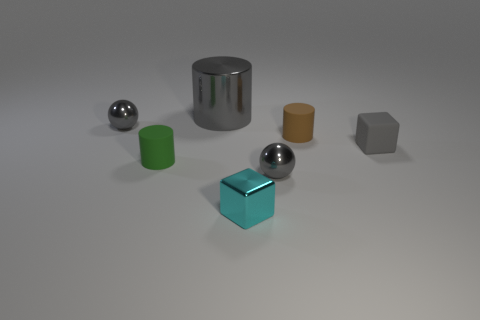Do the large cylinder and the small cylinder that is on the left side of the large gray metallic thing have the same material?
Give a very brief answer. No. The small gray shiny object in front of the metallic thing that is on the left side of the tiny green object is what shape?
Ensure brevity in your answer.  Sphere. There is a gray metallic sphere that is in front of the green object; is it the same size as the big gray object?
Offer a terse response. No. What number of other things are the same shape as the big gray thing?
Give a very brief answer. 2. There is a tiny ball that is behind the tiny brown rubber cylinder; is it the same color as the metallic cylinder?
Offer a very short reply. Yes. Is there a small matte thing of the same color as the big metal cylinder?
Offer a terse response. Yes. There is a rubber block; how many small brown objects are in front of it?
Make the answer very short. 0. What number of other things are there of the same size as the metal cylinder?
Offer a very short reply. 0. Does the cylinder right of the big gray cylinder have the same material as the small ball that is on the left side of the small cyan block?
Keep it short and to the point. No. There is another block that is the same size as the cyan block; what is its color?
Your response must be concise. Gray. 